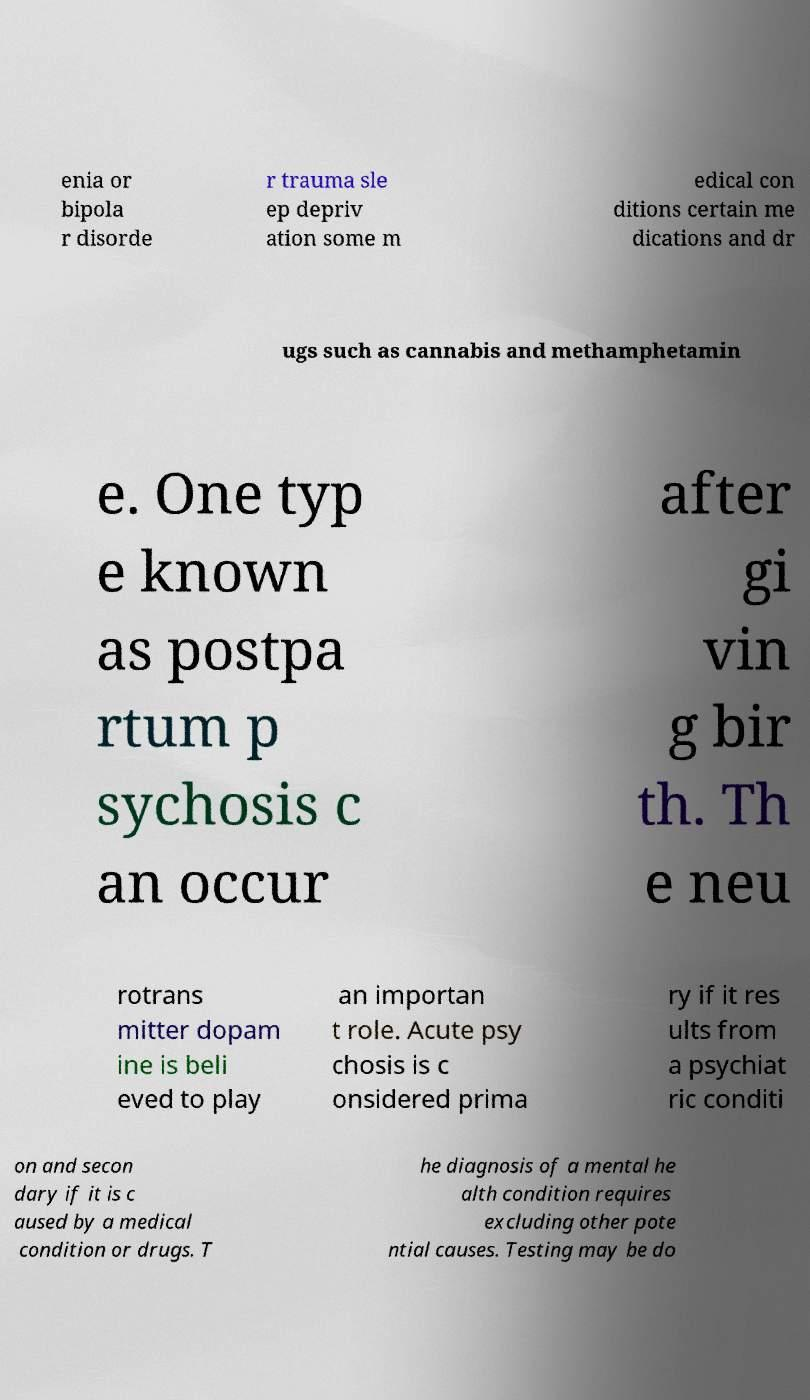For documentation purposes, I need the text within this image transcribed. Could you provide that? enia or bipola r disorde r trauma sle ep depriv ation some m edical con ditions certain me dications and dr ugs such as cannabis and methamphetamin e. One typ e known as postpa rtum p sychosis c an occur after gi vin g bir th. Th e neu rotrans mitter dopam ine is beli eved to play an importan t role. Acute psy chosis is c onsidered prima ry if it res ults from a psychiat ric conditi on and secon dary if it is c aused by a medical condition or drugs. T he diagnosis of a mental he alth condition requires excluding other pote ntial causes. Testing may be do 